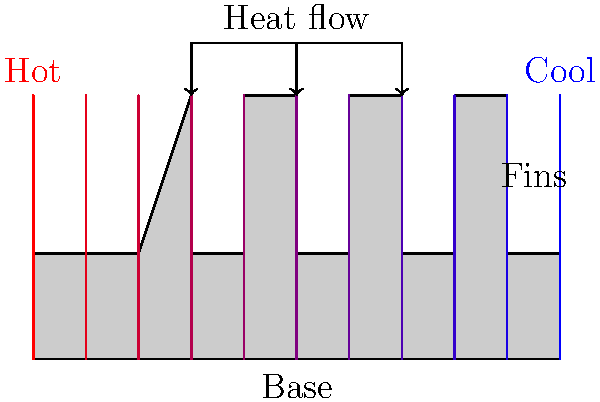In a heat sink with multiple fins, as shown in the diagram, how does the temperature distribution typically vary from the base to the tip of the fins, and what factors influence this distribution? To understand the temperature distribution in a heat sink with multiple fins, we need to consider several factors:

1. Heat conduction: Heat is conducted from the base of the heat sink to the fins. The temperature decreases along the length of the fin due to thermal resistance.

2. Fin efficiency: The effectiveness of a fin in dissipating heat depends on its thermal conductivity, geometry, and length. Longer fins may have lower efficiency at their tips.

3. Heat transfer to the surrounding air: As we move away from the base, more heat is transferred to the surrounding air, causing a temperature gradient.

4. Thermal boundary layer: A layer of air near the fin surface becomes heated, affecting the heat transfer rate along the fin.

5. Fin spacing: The spacing between fins influences air flow and heat transfer effectiveness.

The temperature distribution can be modeled using the fin equation:

$$\frac{d^2\theta}{dx^2} - m^2\theta = 0$$

Where:
$\theta = T(x) - T_{\infty}$ (temperature difference between fin and ambient)
$m^2 = \frac{hP}{kA_c}$ (fin parameter)
$h$ = convective heat transfer coefficient
$P$ = fin perimeter
$k$ = thermal conductivity of the fin material
$A_c$ = cross-sectional area of the fin

The solution to this equation shows an exponential decay in temperature along the fin length:

$$\frac{\theta}{\theta_b} = \frac{\cosh(m(L-x))+\frac{h}{mk}\sinh(m(L-x))}{\cosh(mL)+\frac{h}{mk}\sinh(mL)}$$

Where:
$\theta_b$ = base temperature
$L$ = fin length
$x$ = distance from the base

This equation demonstrates that the temperature decreases more rapidly near the base and approaches ambient temperature towards the tip.
Answer: Temperature decreases exponentially from base to tip, influenced by heat conduction, fin efficiency, air convection, and fin geometry. 